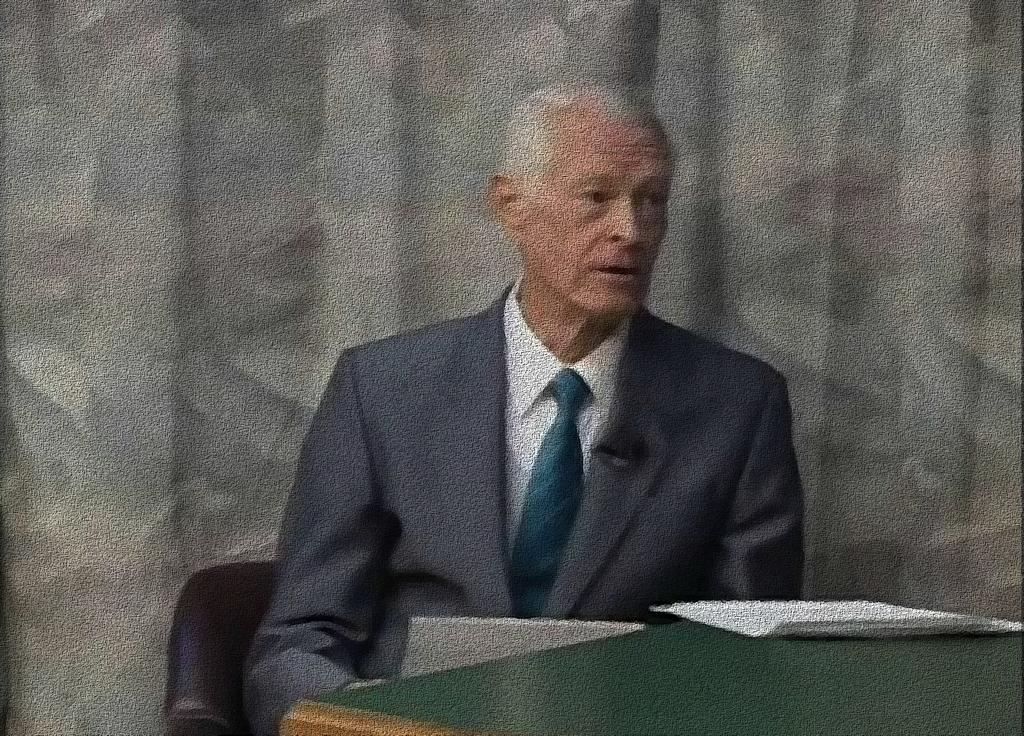What is on the table in the image? There is a paper on the table. What is the man in the image doing? The man is sitting on a chair. What can be seen in the background of the image? There is a curtain in the background. How much money does the man have in his pocket in the image? There is no information about the man's pocket or any money in the image. What type of magic is the man performing in the image? There is no indication of any magic or performance in the image. 